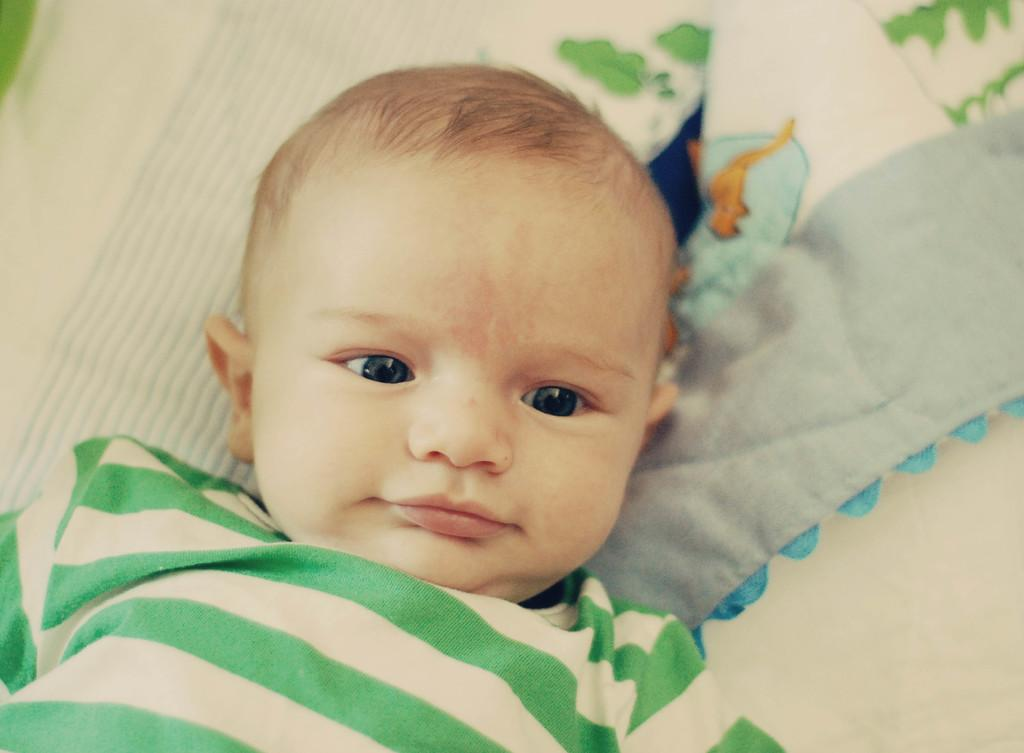What is the main subject of the image? There is a baby in the image. What is the baby wearing? The baby is wearing a white and green striped t-shirt. Where is the baby located in the image? The baby is laying on a bed. What is the rate of the land in the image? There is no land or rate mentioned in the image; it features a baby laying on a bed. 